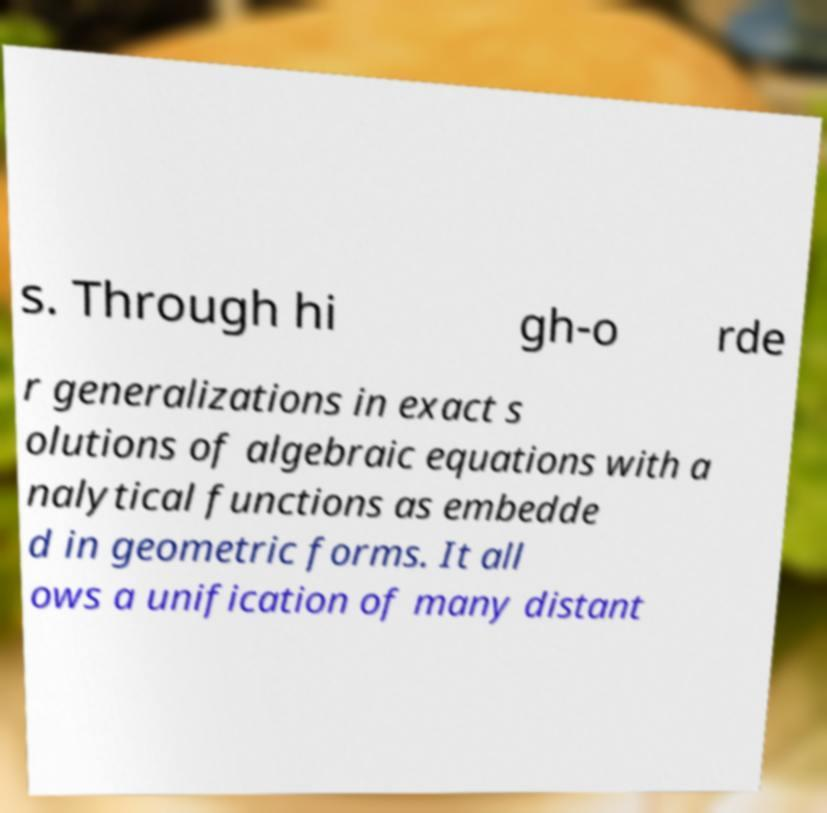I need the written content from this picture converted into text. Can you do that? s. Through hi gh-o rde r generalizations in exact s olutions of algebraic equations with a nalytical functions as embedde d in geometric forms. It all ows a unification of many distant 